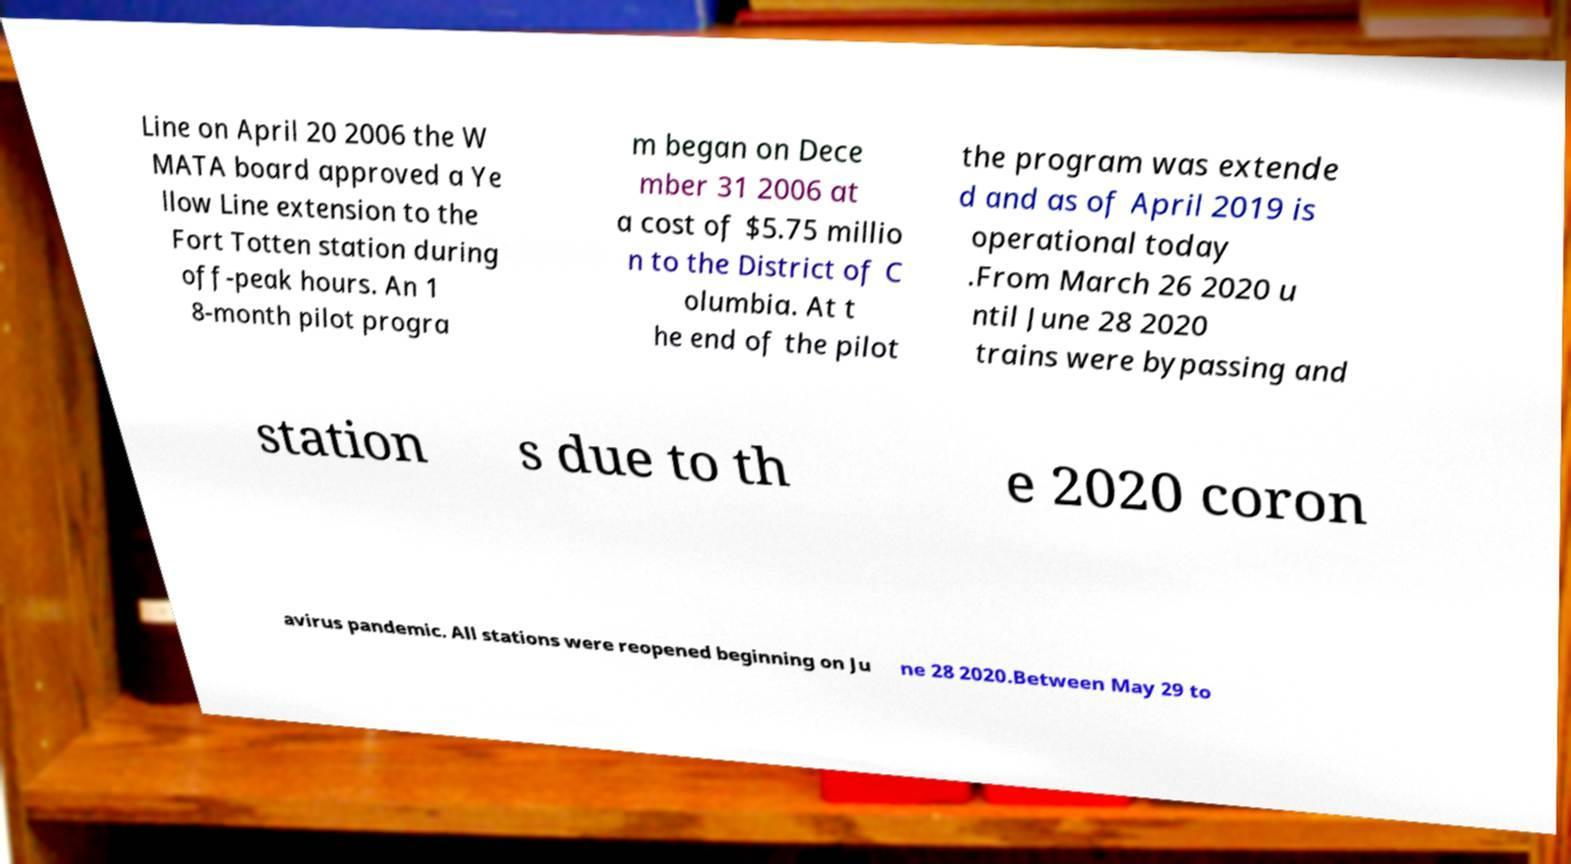Please identify and transcribe the text found in this image. Line on April 20 2006 the W MATA board approved a Ye llow Line extension to the Fort Totten station during off-peak hours. An 1 8-month pilot progra m began on Dece mber 31 2006 at a cost of $5.75 millio n to the District of C olumbia. At t he end of the pilot the program was extende d and as of April 2019 is operational today .From March 26 2020 u ntil June 28 2020 trains were bypassing and station s due to th e 2020 coron avirus pandemic. All stations were reopened beginning on Ju ne 28 2020.Between May 29 to 